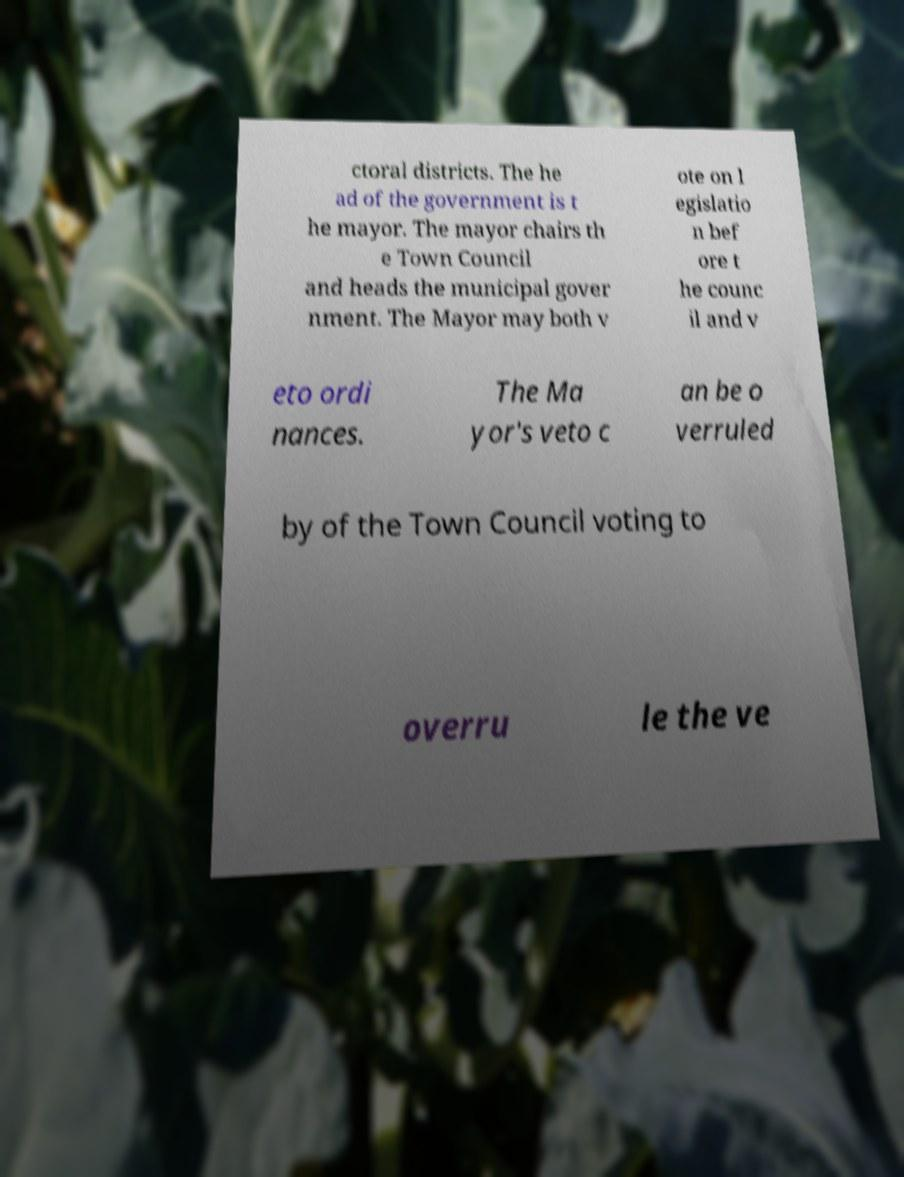Could you extract and type out the text from this image? ctoral districts. The he ad of the government is t he mayor. The mayor chairs th e Town Council and heads the municipal gover nment. The Mayor may both v ote on l egislatio n bef ore t he counc il and v eto ordi nances. The Ma yor's veto c an be o verruled by of the Town Council voting to overru le the ve 